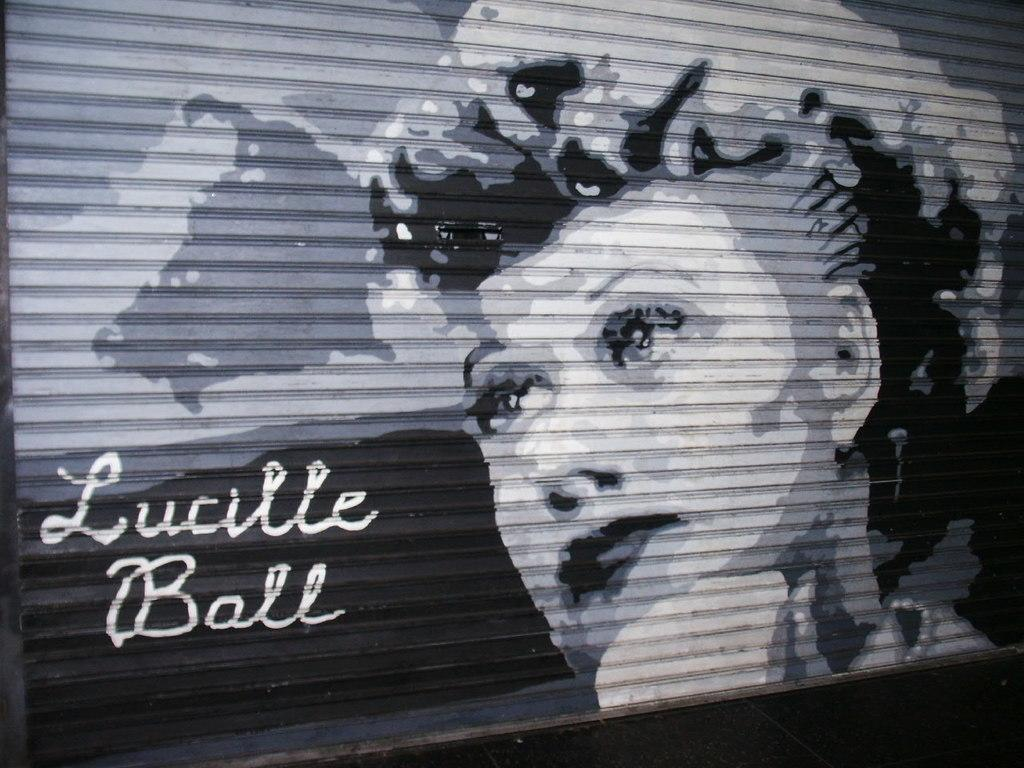What can be seen in the foreground of the image? There is text and an image of a woman on the shutter in the foreground. What is the color of the surface at the bottom of the image? The surface at the bottom of the image is black. Can you hear the woman in the image crying? There is no sound or indication of crying in the image, as it is a still image. Is the image of the woman located inside a cave? There is no mention of a cave in the image or the provided facts. 